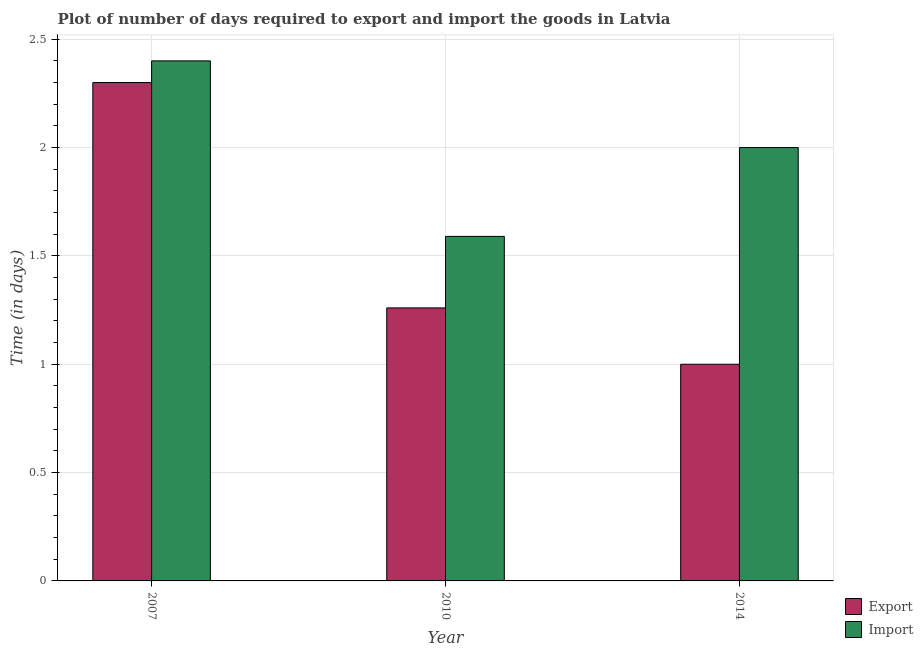How many groups of bars are there?
Your answer should be very brief. 3. What is the label of the 3rd group of bars from the left?
Offer a very short reply. 2014. What is the time required to export in 2007?
Your response must be concise. 2.3. Across all years, what is the maximum time required to import?
Ensure brevity in your answer.  2.4. Across all years, what is the minimum time required to import?
Ensure brevity in your answer.  1.59. In which year was the time required to import maximum?
Your answer should be very brief. 2007. In which year was the time required to import minimum?
Offer a terse response. 2010. What is the total time required to import in the graph?
Ensure brevity in your answer.  5.99. What is the difference between the time required to export in 2010 and that in 2014?
Make the answer very short. 0.26. What is the difference between the time required to export in 2014 and the time required to import in 2007?
Your response must be concise. -1.3. What is the average time required to export per year?
Make the answer very short. 1.52. In how many years, is the time required to import greater than 0.8 days?
Give a very brief answer. 3. What is the ratio of the time required to import in 2007 to that in 2014?
Your answer should be compact. 1.2. Is the time required to import in 2010 less than that in 2014?
Make the answer very short. Yes. What is the difference between the highest and the second highest time required to import?
Give a very brief answer. 0.4. What is the difference between the highest and the lowest time required to import?
Your response must be concise. 0.81. In how many years, is the time required to export greater than the average time required to export taken over all years?
Make the answer very short. 1. What does the 2nd bar from the left in 2014 represents?
Keep it short and to the point. Import. What does the 1st bar from the right in 2014 represents?
Ensure brevity in your answer.  Import. Are all the bars in the graph horizontal?
Make the answer very short. No. How many years are there in the graph?
Make the answer very short. 3. Are the values on the major ticks of Y-axis written in scientific E-notation?
Your answer should be compact. No. Does the graph contain any zero values?
Your answer should be very brief. No. Where does the legend appear in the graph?
Make the answer very short. Bottom right. What is the title of the graph?
Provide a succinct answer. Plot of number of days required to export and import the goods in Latvia. Does "Highest 20% of population" appear as one of the legend labels in the graph?
Offer a terse response. No. What is the label or title of the Y-axis?
Your answer should be compact. Time (in days). What is the Time (in days) of Import in 2007?
Your answer should be very brief. 2.4. What is the Time (in days) of Export in 2010?
Offer a terse response. 1.26. What is the Time (in days) of Import in 2010?
Your answer should be very brief. 1.59. What is the Time (in days) of Export in 2014?
Ensure brevity in your answer.  1. Across all years, what is the maximum Time (in days) in Export?
Offer a very short reply. 2.3. Across all years, what is the minimum Time (in days) of Import?
Ensure brevity in your answer.  1.59. What is the total Time (in days) of Export in the graph?
Offer a terse response. 4.56. What is the total Time (in days) of Import in the graph?
Your answer should be very brief. 5.99. What is the difference between the Time (in days) of Import in 2007 and that in 2010?
Make the answer very short. 0.81. What is the difference between the Time (in days) of Export in 2007 and that in 2014?
Provide a succinct answer. 1.3. What is the difference between the Time (in days) in Export in 2010 and that in 2014?
Offer a terse response. 0.26. What is the difference between the Time (in days) in Import in 2010 and that in 2014?
Provide a succinct answer. -0.41. What is the difference between the Time (in days) of Export in 2007 and the Time (in days) of Import in 2010?
Provide a succinct answer. 0.71. What is the difference between the Time (in days) of Export in 2010 and the Time (in days) of Import in 2014?
Keep it short and to the point. -0.74. What is the average Time (in days) of Export per year?
Provide a short and direct response. 1.52. What is the average Time (in days) of Import per year?
Your response must be concise. 2. In the year 2010, what is the difference between the Time (in days) of Export and Time (in days) of Import?
Make the answer very short. -0.33. In the year 2014, what is the difference between the Time (in days) of Export and Time (in days) of Import?
Your answer should be very brief. -1. What is the ratio of the Time (in days) of Export in 2007 to that in 2010?
Your answer should be very brief. 1.83. What is the ratio of the Time (in days) in Import in 2007 to that in 2010?
Offer a terse response. 1.51. What is the ratio of the Time (in days) in Export in 2010 to that in 2014?
Provide a short and direct response. 1.26. What is the ratio of the Time (in days) in Import in 2010 to that in 2014?
Your answer should be very brief. 0.8. What is the difference between the highest and the second highest Time (in days) of Export?
Provide a succinct answer. 1.04. What is the difference between the highest and the second highest Time (in days) in Import?
Make the answer very short. 0.4. What is the difference between the highest and the lowest Time (in days) of Import?
Offer a terse response. 0.81. 